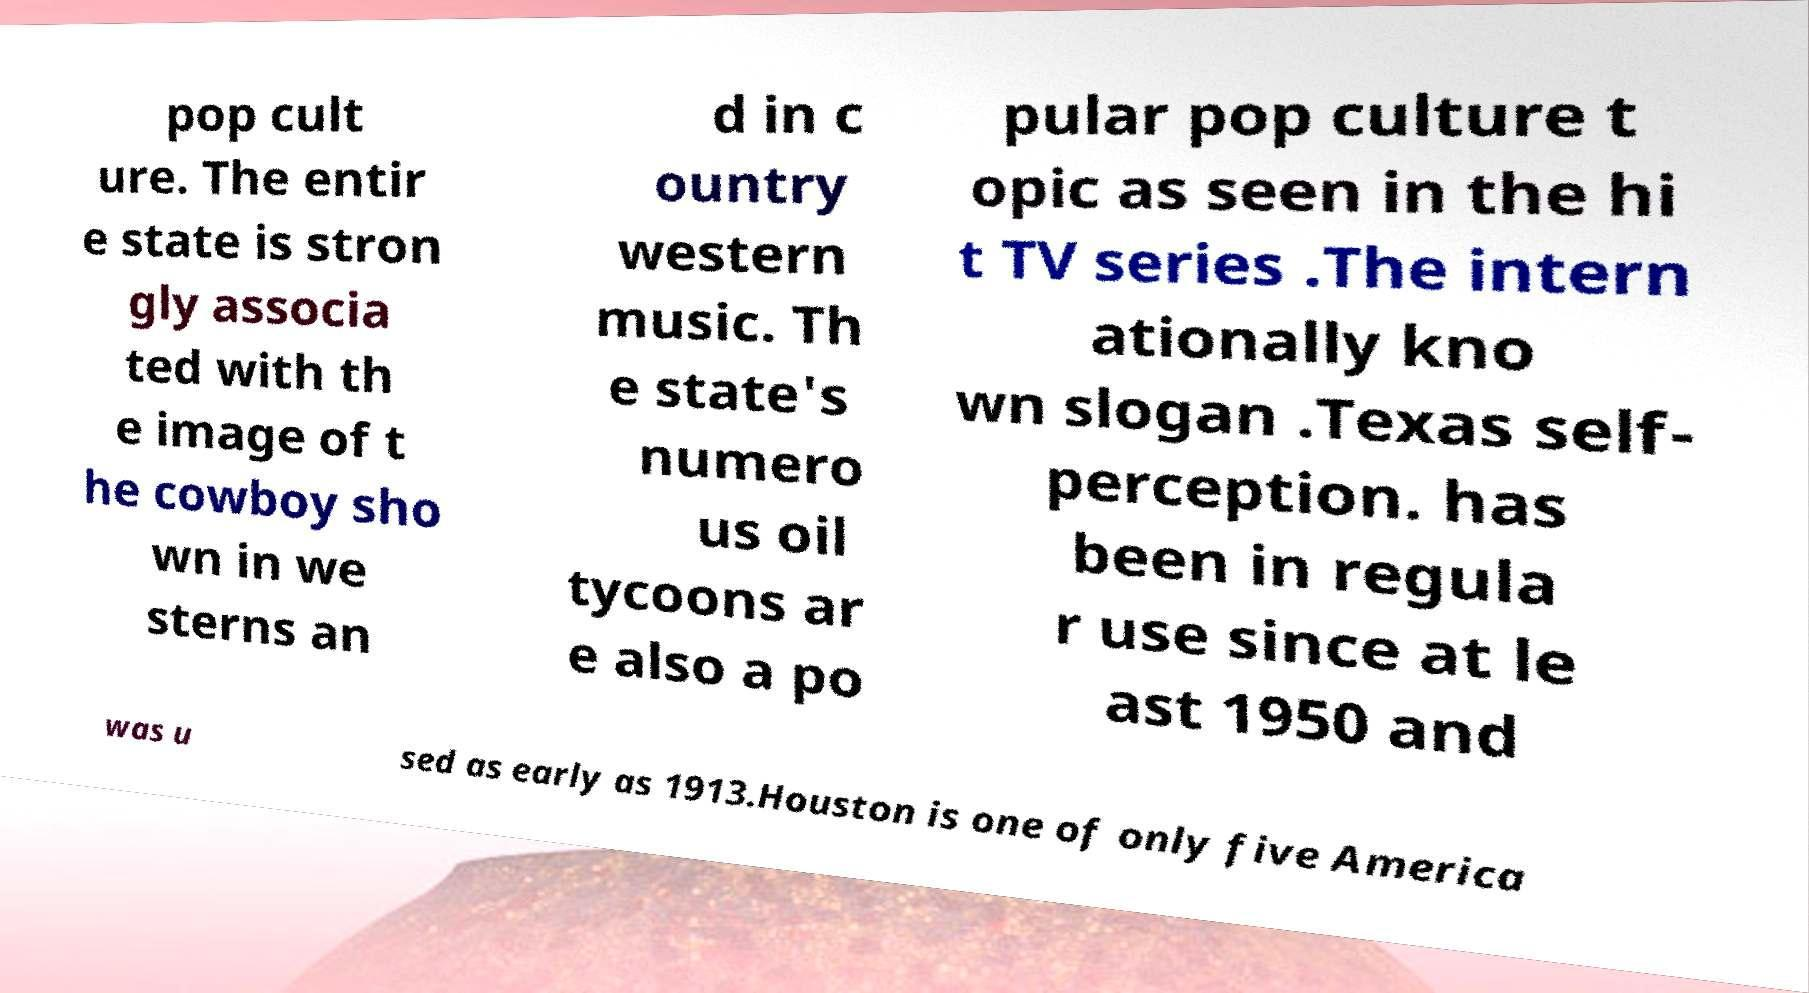There's text embedded in this image that I need extracted. Can you transcribe it verbatim? pop cult ure. The entir e state is stron gly associa ted with th e image of t he cowboy sho wn in we sterns an d in c ountry western music. Th e state's numero us oil tycoons ar e also a po pular pop culture t opic as seen in the hi t TV series .The intern ationally kno wn slogan .Texas self- perception. has been in regula r use since at le ast 1950 and was u sed as early as 1913.Houston is one of only five America 